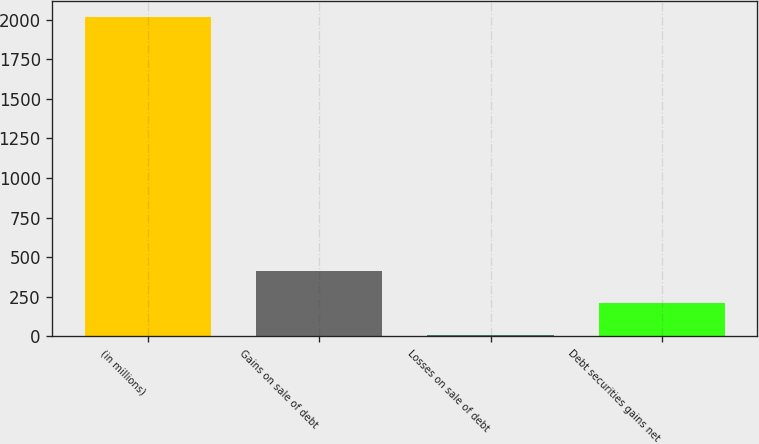Convert chart. <chart><loc_0><loc_0><loc_500><loc_500><bar_chart><fcel>(in millions)<fcel>Gains on sale of debt<fcel>Losses on sale of debt<fcel>Debt securities gains net<nl><fcel>2015<fcel>412.6<fcel>12<fcel>212.3<nl></chart> 